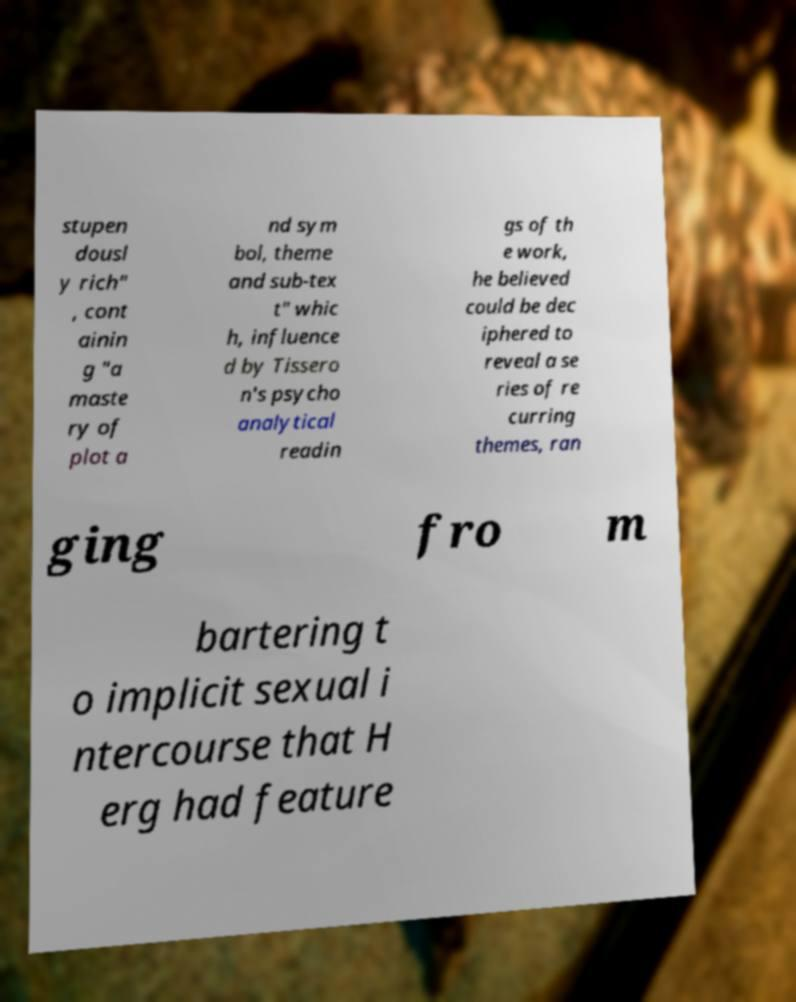For documentation purposes, I need the text within this image transcribed. Could you provide that? stupen dousl y rich" , cont ainin g "a maste ry of plot a nd sym bol, theme and sub-tex t" whic h, influence d by Tissero n's psycho analytical readin gs of th e work, he believed could be dec iphered to reveal a se ries of re curring themes, ran ging fro m bartering t o implicit sexual i ntercourse that H erg had feature 